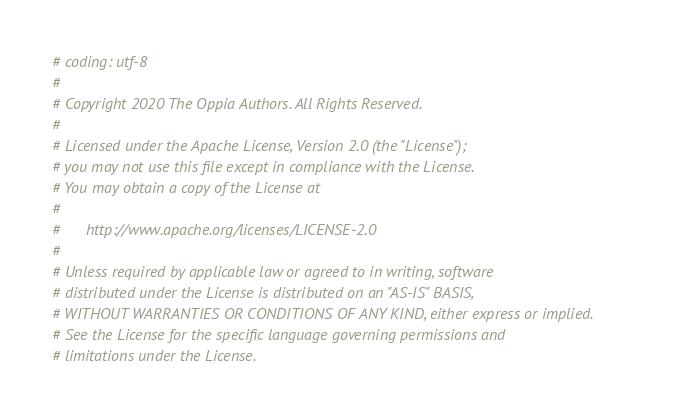Convert code to text. <code><loc_0><loc_0><loc_500><loc_500><_Python_># coding: utf-8
#
# Copyright 2020 The Oppia Authors. All Rights Reserved.
#
# Licensed under the Apache License, Version 2.0 (the "License");
# you may not use this file except in compliance with the License.
# You may obtain a copy of the License at
#
#      http://www.apache.org/licenses/LICENSE-2.0
#
# Unless required by applicable law or agreed to in writing, software
# distributed under the License is distributed on an "AS-IS" BASIS,
# WITHOUT WARRANTIES OR CONDITIONS OF ANY KIND, either express or implied.
# See the License for the specific language governing permissions and
# limitations under the License.
</code> 